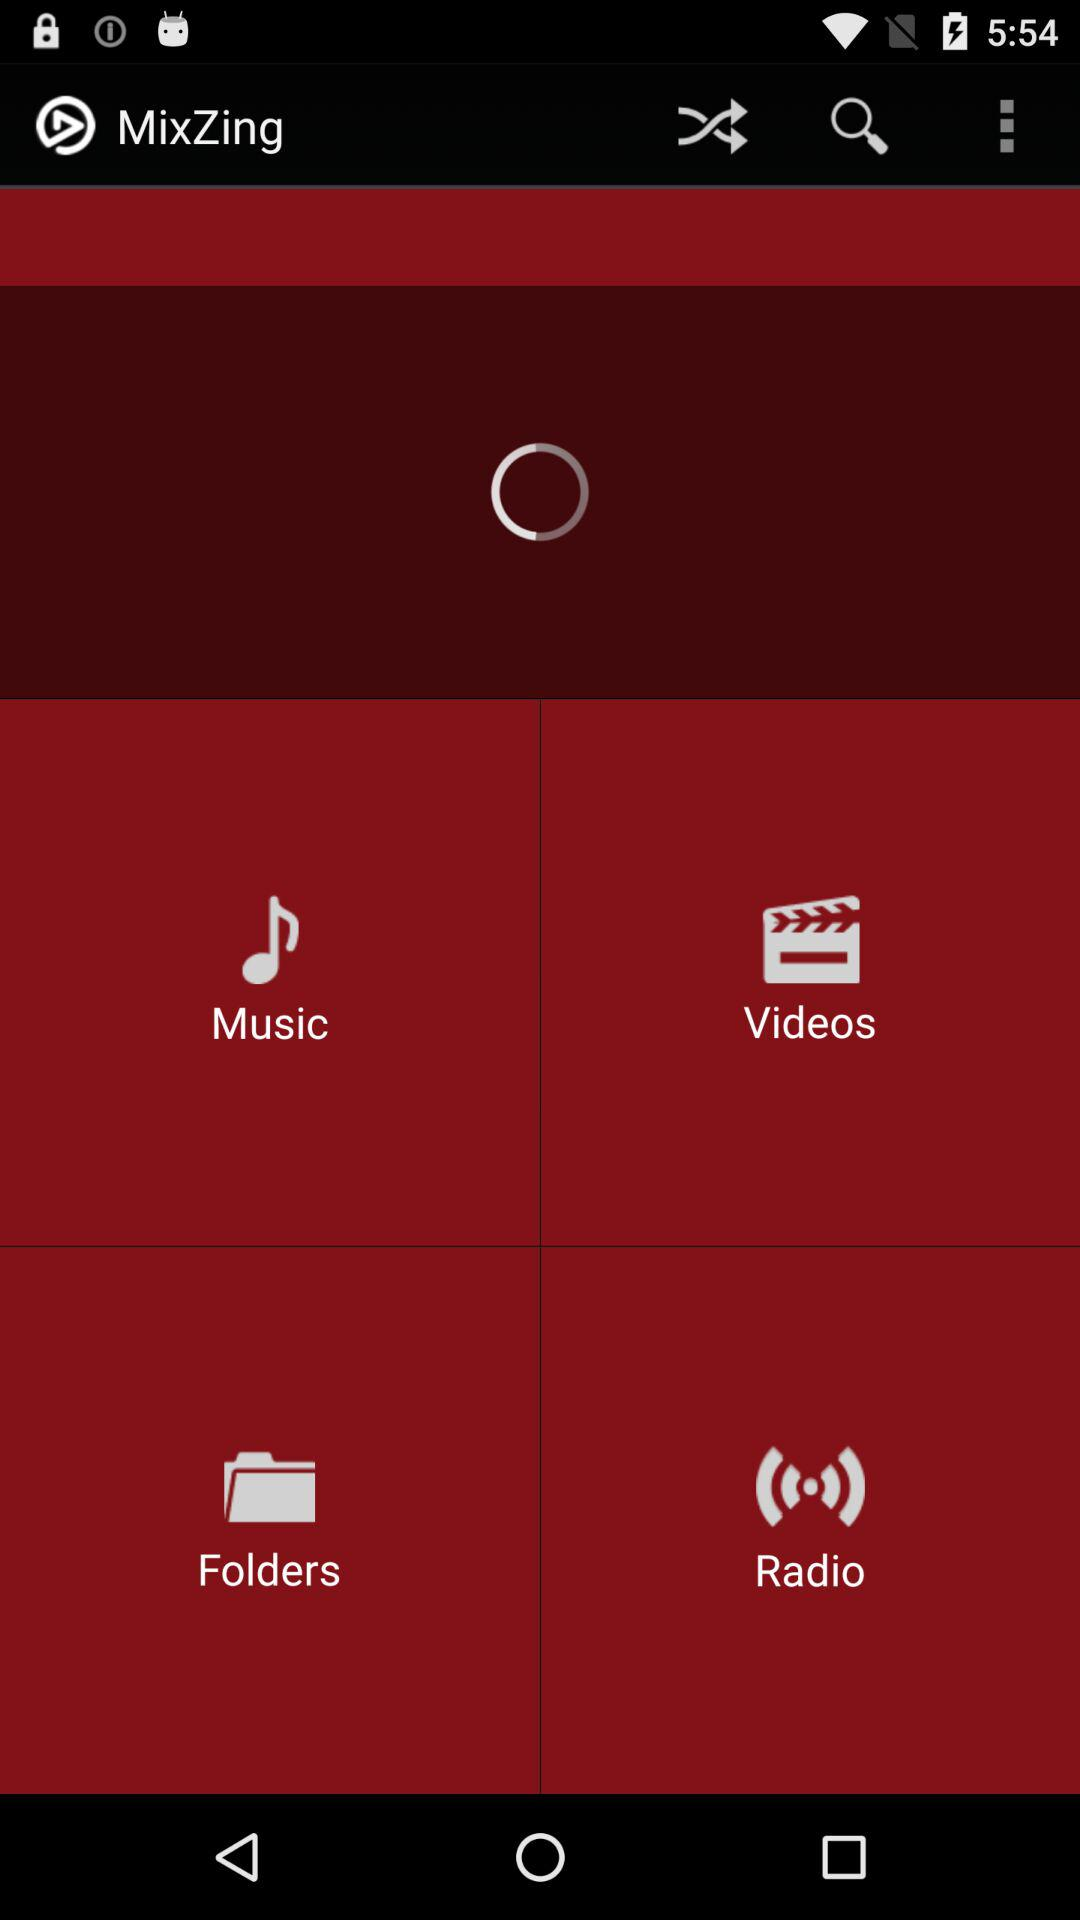What is the app name? The app name is "MixZing". 